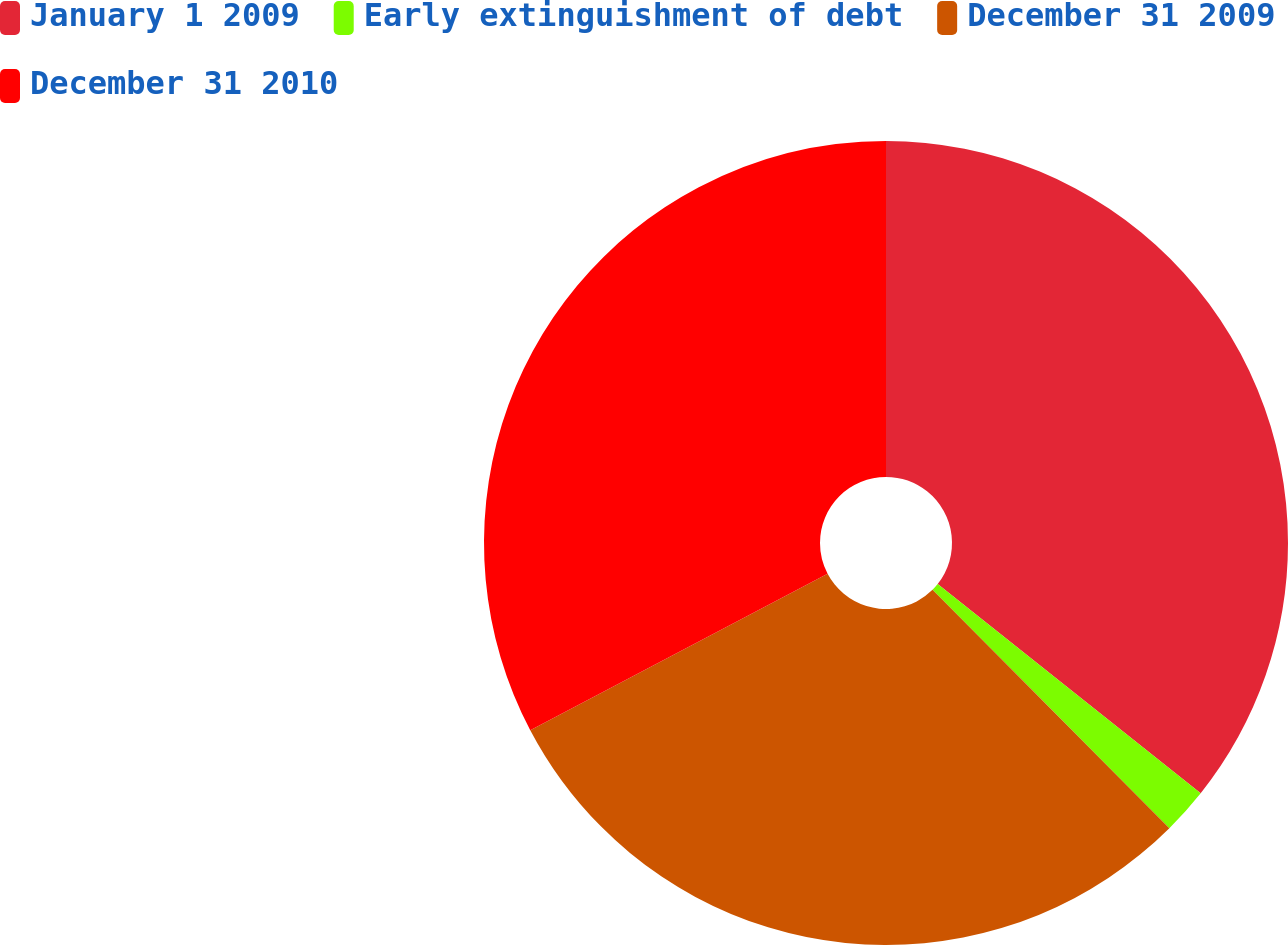Convert chart. <chart><loc_0><loc_0><loc_500><loc_500><pie_chart><fcel>January 1 2009<fcel>Early extinguishment of debt<fcel>December 31 2009<fcel>December 31 2010<nl><fcel>35.69%<fcel>1.86%<fcel>29.74%<fcel>32.71%<nl></chart> 